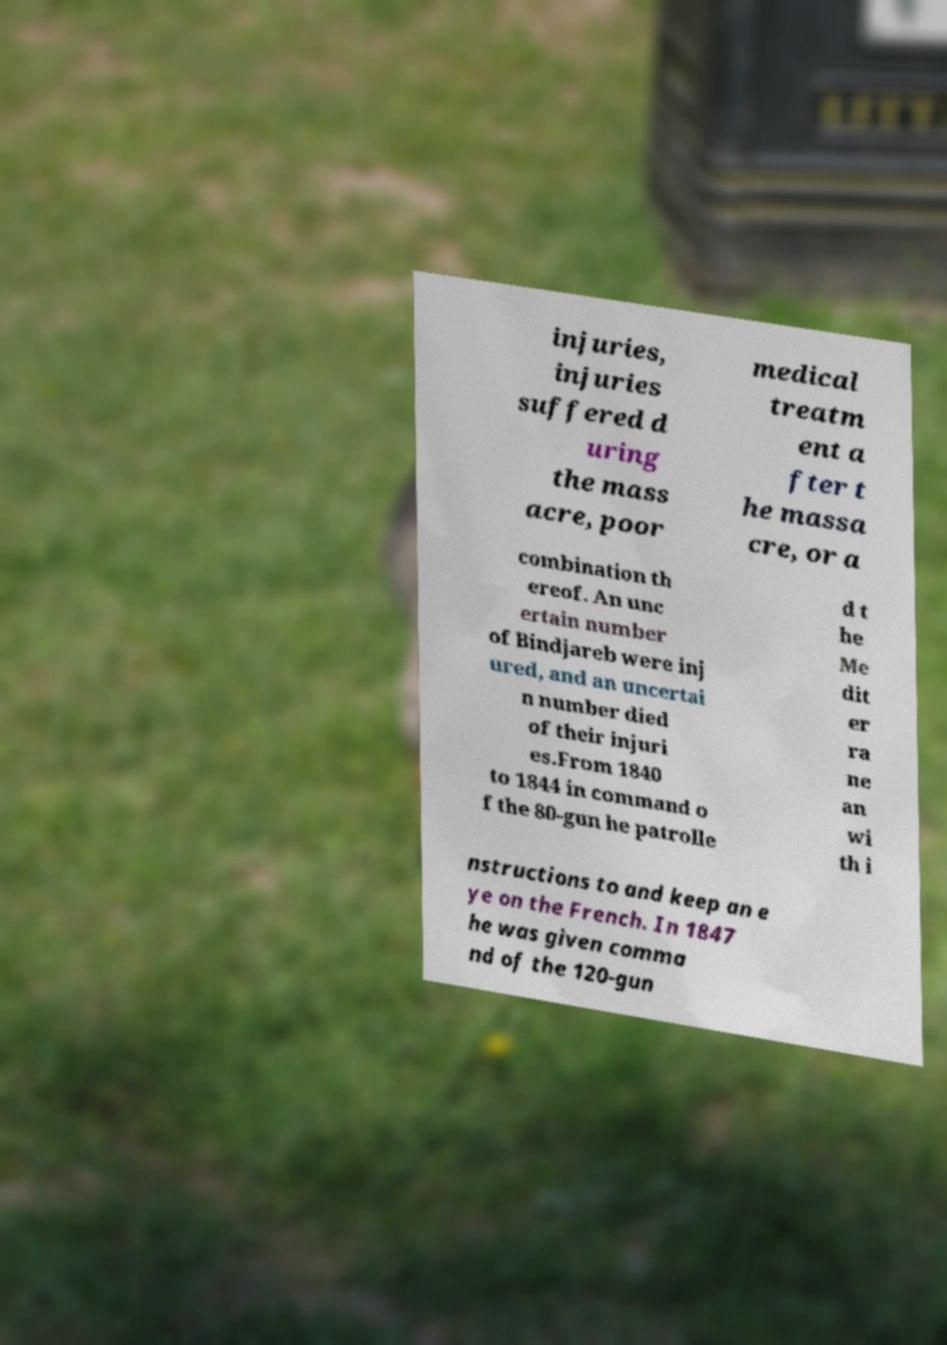Please identify and transcribe the text found in this image. injuries, injuries suffered d uring the mass acre, poor medical treatm ent a fter t he massa cre, or a combination th ereof. An unc ertain number of Bindjareb were inj ured, and an uncertai n number died of their injuri es.From 1840 to 1844 in command o f the 80-gun he patrolle d t he Me dit er ra ne an wi th i nstructions to and keep an e ye on the French. In 1847 he was given comma nd of the 120-gun 